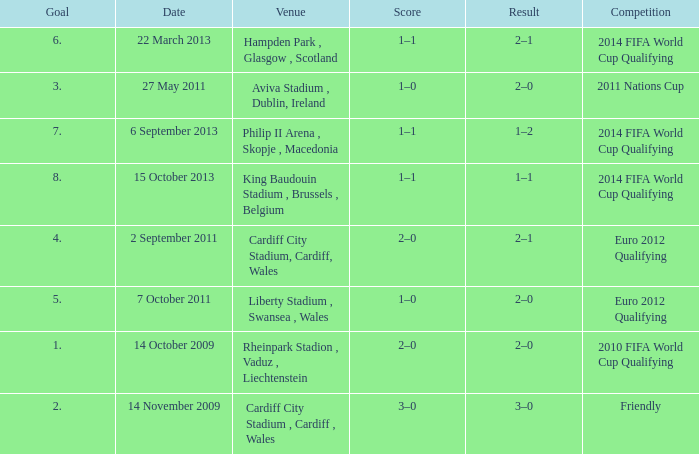What is the Venue for Goal number 1? Rheinpark Stadion , Vaduz , Liechtenstein. 